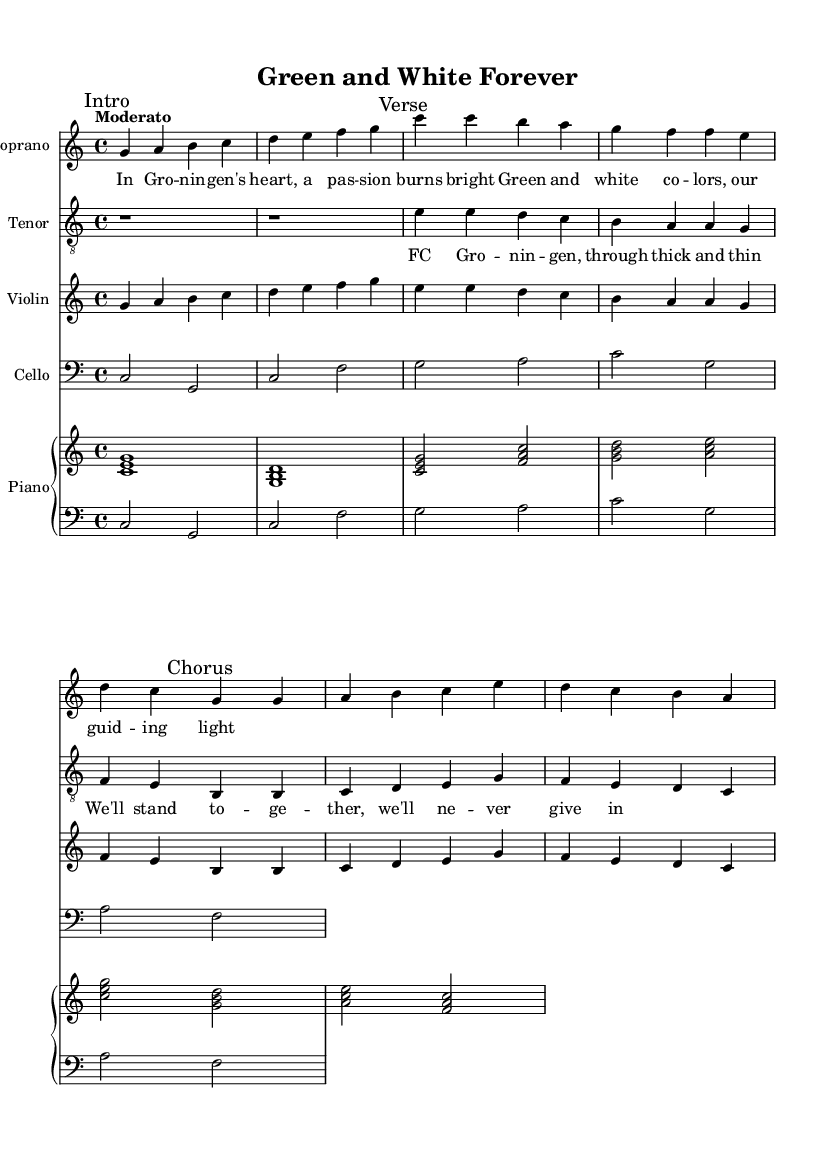What is the key signature of this music? The key signature is indicated at the beginning of the music, showing no sharps or flats, which signifies C major.
Answer: C major What is the time signature of the piece? The time signature is found at the beginning of the music; it shows a 4 over 4, indicating that there are four beats in each measure.
Answer: 4/4 What is the tempo marking of the piece? The tempo marking is provided just above the staff; it suggests the piece should be played "Moderato," meaning moderately.
Answer: Moderato How many measures are there in the intro? By counting the measures in the intro section, you can see there are a total of 4 measures present.
Answer: 4 What instruments are featured in this score? By looking at the different labeled staves, we can see that instruments include Soprano, Tenor, Violin, Cello, and Piano.
Answer: Soprano, Tenor, Violin, Cello, Piano What is the title of this opera? The title is noted in the header of the sheet music, which clearly states "Green and White Forever."
Answer: Green and White Forever What is the theme of the lyrics in this piece? The lyrics express a sense of passion and loyalty to FC Groningen, reflected through phrases about standing together and perseverance.
Answer: Passion and loyalty to FC Groningen 